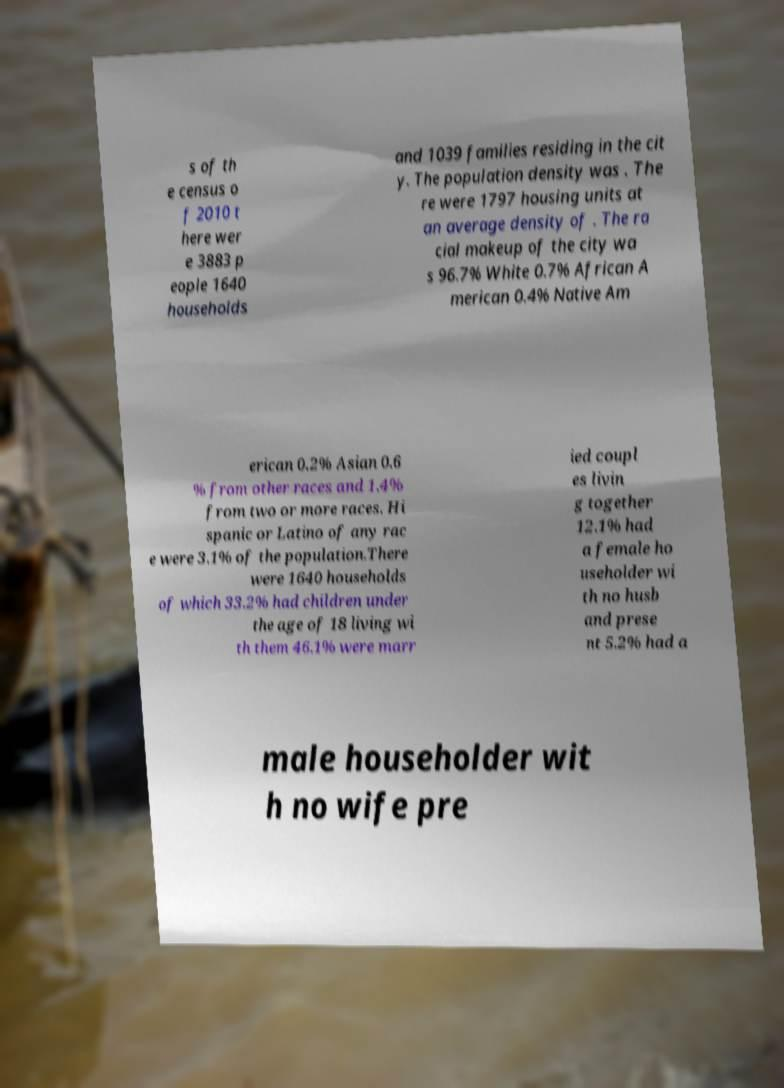Can you accurately transcribe the text from the provided image for me? s of th e census o f 2010 t here wer e 3883 p eople 1640 households and 1039 families residing in the cit y. The population density was . The re were 1797 housing units at an average density of . The ra cial makeup of the city wa s 96.7% White 0.7% African A merican 0.4% Native Am erican 0.2% Asian 0.6 % from other races and 1.4% from two or more races. Hi spanic or Latino of any rac e were 3.1% of the population.There were 1640 households of which 33.2% had children under the age of 18 living wi th them 46.1% were marr ied coupl es livin g together 12.1% had a female ho useholder wi th no husb and prese nt 5.2% had a male householder wit h no wife pre 